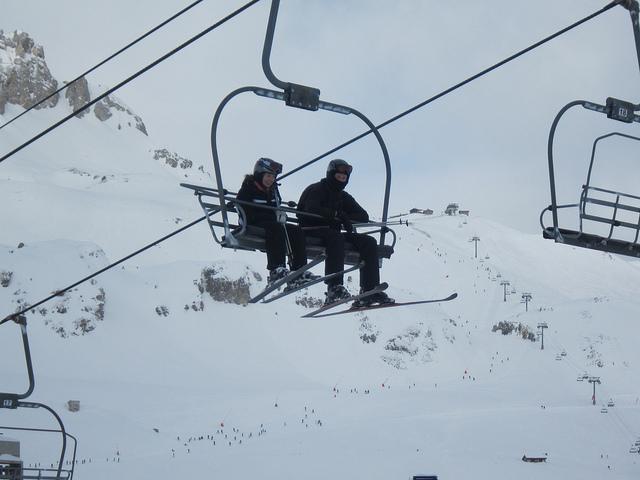The ski lift saves the skiers from a lot of what physical activity?
Select the correct answer and articulate reasoning with the following format: 'Answer: answer
Rationale: rationale.'
Options: Rollerskating, swimming, walking, skipping. Answer: walking.
Rationale: They use this to take them up the mountain so they do not have to walk which would take a long time. 